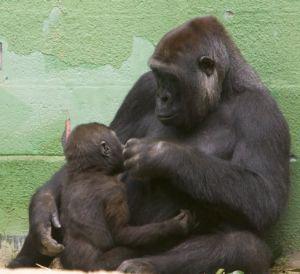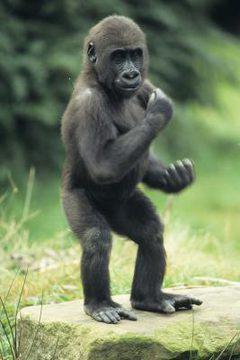The first image is the image on the left, the second image is the image on the right. For the images shown, is this caption "An ape is standing on two legs." true? Answer yes or no. Yes. The first image is the image on the left, the second image is the image on the right. Evaluate the accuracy of this statement regarding the images: "The right image contains one gorilla standing upright on two legs.". Is it true? Answer yes or no. Yes. 